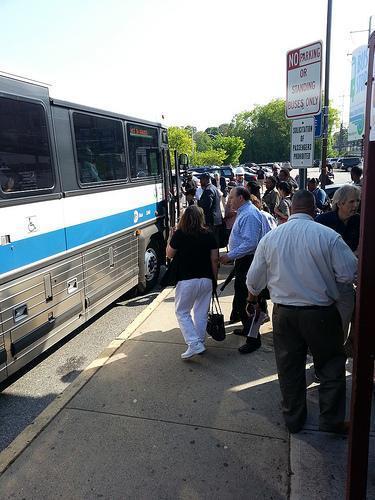How many buses are there?
Give a very brief answer. 1. 